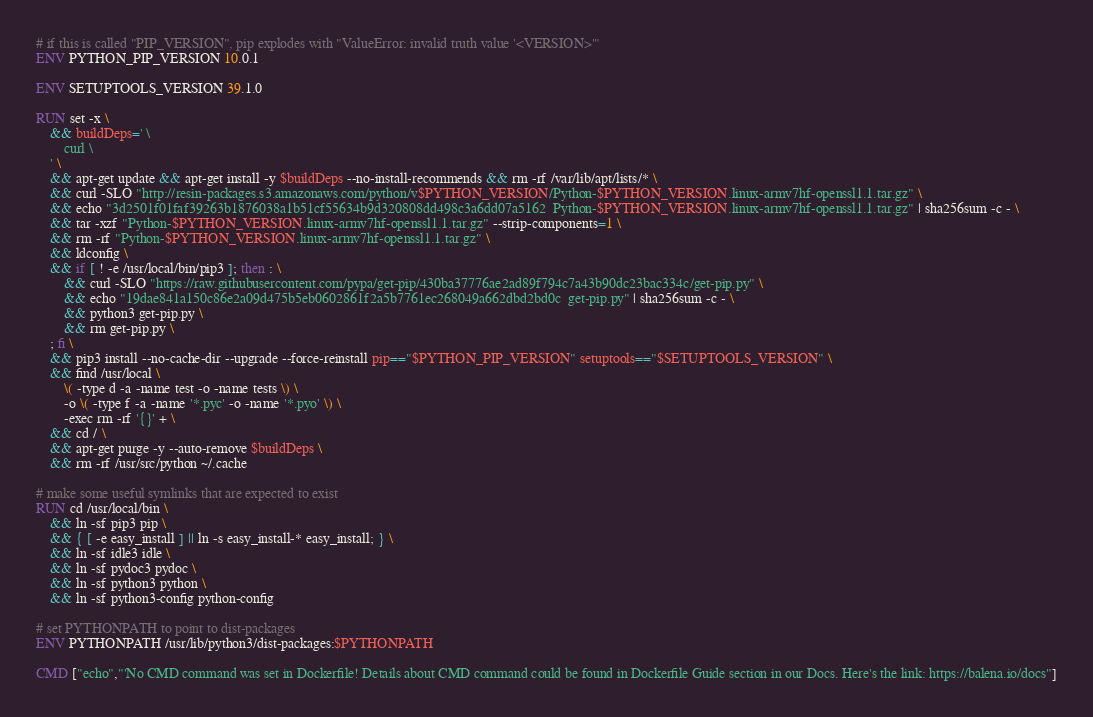<code> <loc_0><loc_0><loc_500><loc_500><_Dockerfile_># if this is called "PIP_VERSION", pip explodes with "ValueError: invalid truth value '<VERSION>'"
ENV PYTHON_PIP_VERSION 10.0.1

ENV SETUPTOOLS_VERSION 39.1.0

RUN set -x \
	&& buildDeps=' \
		curl \
	' \
	&& apt-get update && apt-get install -y $buildDeps --no-install-recommends && rm -rf /var/lib/apt/lists/* \
	&& curl -SLO "http://resin-packages.s3.amazonaws.com/python/v$PYTHON_VERSION/Python-$PYTHON_VERSION.linux-armv7hf-openssl1.1.tar.gz" \
	&& echo "3d2501f01faf39263b1876038a1b51cf55634b9d320808dd498c3a6dd07a5162  Python-$PYTHON_VERSION.linux-armv7hf-openssl1.1.tar.gz" | sha256sum -c - \
	&& tar -xzf "Python-$PYTHON_VERSION.linux-armv7hf-openssl1.1.tar.gz" --strip-components=1 \
	&& rm -rf "Python-$PYTHON_VERSION.linux-armv7hf-openssl1.1.tar.gz" \
	&& ldconfig \
	&& if [ ! -e /usr/local/bin/pip3 ]; then : \
		&& curl -SLO "https://raw.githubusercontent.com/pypa/get-pip/430ba37776ae2ad89f794c7a43b90dc23bac334c/get-pip.py" \
		&& echo "19dae841a150c86e2a09d475b5eb0602861f2a5b7761ec268049a662dbd2bd0c  get-pip.py" | sha256sum -c - \
		&& python3 get-pip.py \
		&& rm get-pip.py \
	; fi \
	&& pip3 install --no-cache-dir --upgrade --force-reinstall pip=="$PYTHON_PIP_VERSION" setuptools=="$SETUPTOOLS_VERSION" \
	&& find /usr/local \
		\( -type d -a -name test -o -name tests \) \
		-o \( -type f -a -name '*.pyc' -o -name '*.pyo' \) \
		-exec rm -rf '{}' + \
	&& cd / \
	&& apt-get purge -y --auto-remove $buildDeps \
	&& rm -rf /usr/src/python ~/.cache

# make some useful symlinks that are expected to exist
RUN cd /usr/local/bin \
	&& ln -sf pip3 pip \
	&& { [ -e easy_install ] || ln -s easy_install-* easy_install; } \
	&& ln -sf idle3 idle \
	&& ln -sf pydoc3 pydoc \
	&& ln -sf python3 python \
	&& ln -sf python3-config python-config

# set PYTHONPATH to point to dist-packages
ENV PYTHONPATH /usr/lib/python3/dist-packages:$PYTHONPATH

CMD ["echo","'No CMD command was set in Dockerfile! Details about CMD command could be found in Dockerfile Guide section in our Docs. Here's the link: https://balena.io/docs"]</code> 